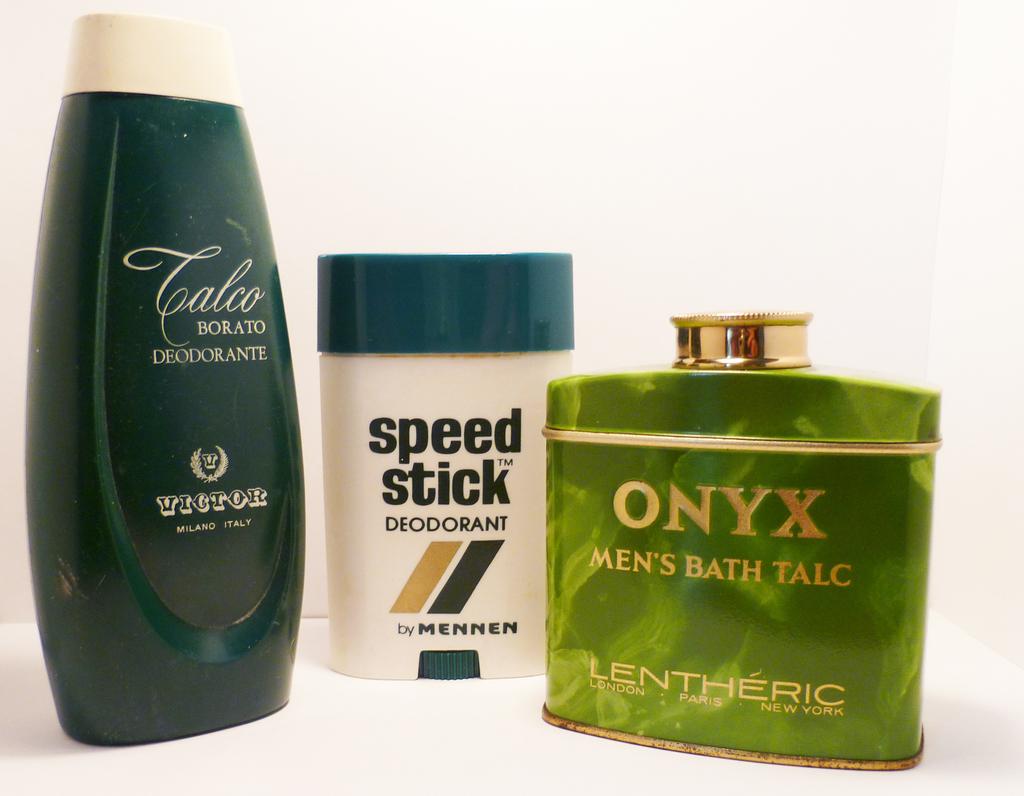What gender is the talc geared towards?
Give a very brief answer. Men. What brand of deodorant is pictured?
Ensure brevity in your answer.  Speed stick. 